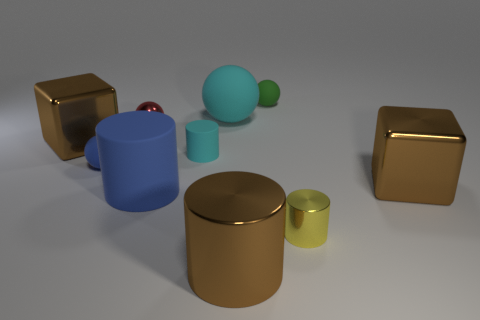Subtract all yellow balls. Subtract all blue cubes. How many balls are left? 4 Subtract all cubes. How many objects are left? 8 Add 3 big brown objects. How many big brown objects are left? 6 Add 6 big cubes. How many big cubes exist? 8 Subtract 0 purple cylinders. How many objects are left? 10 Subtract all yellow things. Subtract all big gray metallic cylinders. How many objects are left? 9 